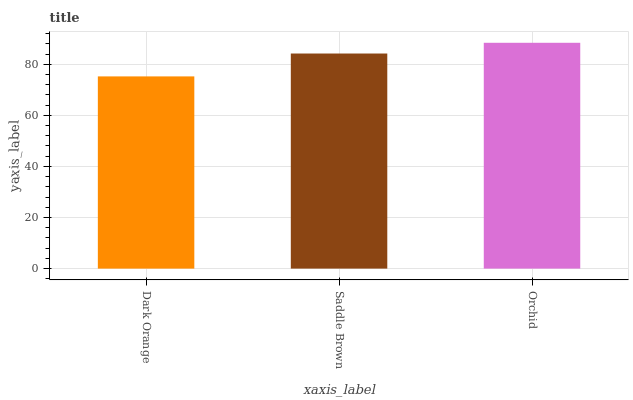Is Saddle Brown the minimum?
Answer yes or no. No. Is Saddle Brown the maximum?
Answer yes or no. No. Is Saddle Brown greater than Dark Orange?
Answer yes or no. Yes. Is Dark Orange less than Saddle Brown?
Answer yes or no. Yes. Is Dark Orange greater than Saddle Brown?
Answer yes or no. No. Is Saddle Brown less than Dark Orange?
Answer yes or no. No. Is Saddle Brown the high median?
Answer yes or no. Yes. Is Saddle Brown the low median?
Answer yes or no. Yes. Is Dark Orange the high median?
Answer yes or no. No. Is Dark Orange the low median?
Answer yes or no. No. 